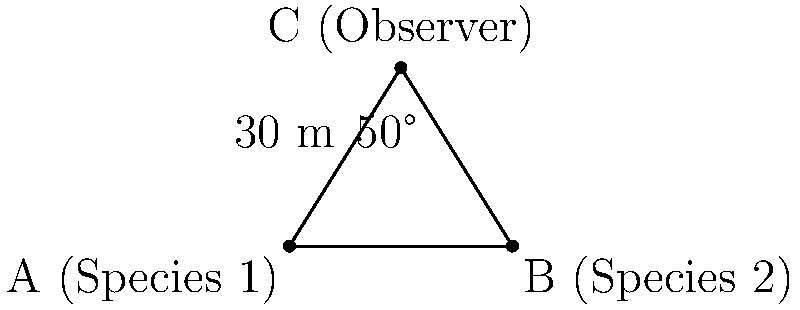A biologist is studying two species of plants located on opposite sides of a pond. The observer stands at point C and measures the angle between the two species (A and B) to be 50°. The distance from the observer to Species 1 (point A) is 30 meters. Using trigonometric functions, determine the distance between the two species of plants (length AB). Let's approach this step-by-step:

1) First, we need to identify the triangle and the known information:
   - We have a triangle ABC
   - Angle ACB = 50°
   - AC (distance from observer to Species 1) = 30 m
   - We need to find AB (distance between the two species)

2) We can split this triangle into two right triangles by drawing a perpendicular line from C to AB.

3) In the right triangle formed, we know:
   - The hypotenuse (AC) = 30 m
   - One angle is 90° (the one we just created)
   - The other angle is 25° (half of 50°, as we split the original angle in two)

4) We can use the cosine function to find the base of this right triangle:
   $\cos(25°) = \frac{\text{adjacent}}{\text{hypotenuse}} = \frac{x}{30}$

5) Solving for x:
   $x = 30 \cos(25°) \approx 27.19$ m

6) This length (27.19 m) is half of AB, so we need to double it:
   $AB = 2 * 27.19 = 54.38$ m

Therefore, the distance between the two species is approximately 54.38 meters.
Answer: 54.38 m 